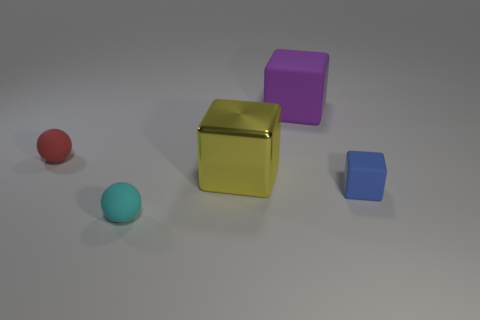How many big cubes are there?
Provide a short and direct response. 2. Are there an equal number of blue things that are on the left side of the large yellow metal cube and red matte objects that are to the right of the big purple object?
Provide a short and direct response. Yes. There is a purple matte block; are there any tiny matte blocks left of it?
Offer a terse response. No. There is a matte sphere that is to the right of the small red matte sphere; what color is it?
Ensure brevity in your answer.  Cyan. What material is the thing that is on the left side of the cyan rubber sphere to the left of the large yellow object?
Provide a succinct answer. Rubber. Are there fewer big blocks that are behind the purple cube than cyan matte things left of the small red sphere?
Your answer should be compact. No. How many cyan objects are either spheres or metallic blocks?
Ensure brevity in your answer.  1. Are there the same number of blue matte things that are left of the tiny blue cube and large purple matte things?
Your response must be concise. No. How many objects are cyan balls or small spheres behind the tiny cyan ball?
Give a very brief answer. 2. Is the color of the large rubber block the same as the small rubber cube?
Ensure brevity in your answer.  No. 